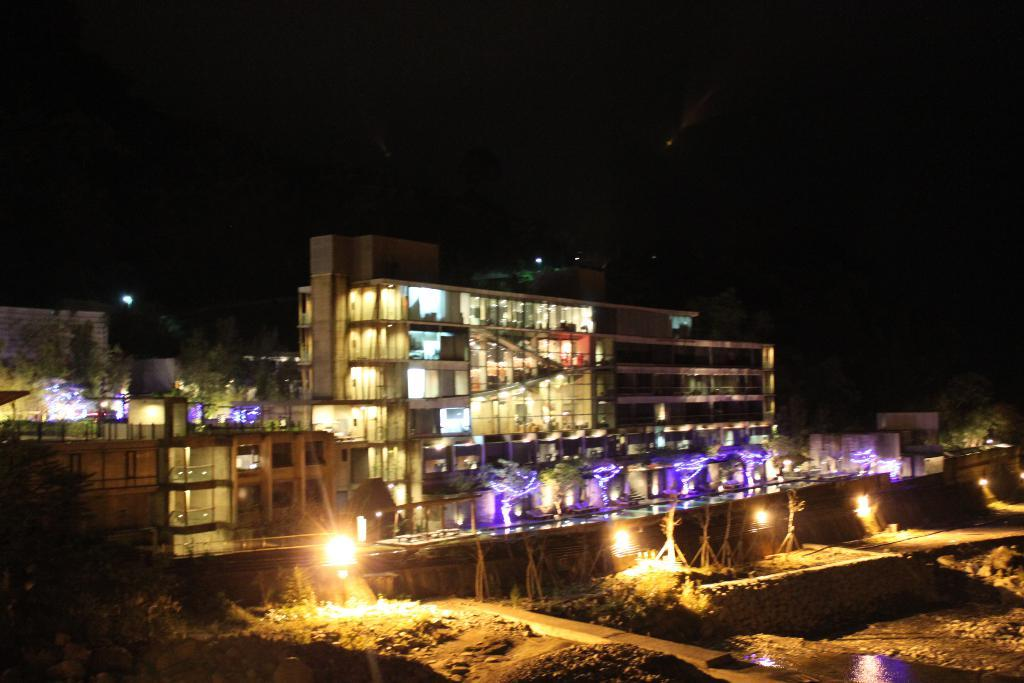What type of structures can be seen in the image? There are buildings in the image. What feature can be observed on the buildings? There are windows visible in the image. What can be seen illuminating the scene? There are lights in the image. What type of vegetation is present in the image? There are plants and trees in the image. Can you see a snail crawling on the apple in the image? There is no apple or snail present in the image. What type of kitty can be seen playing with the plants in the image? There is no kitty present in the image; only plants and trees are visible. 